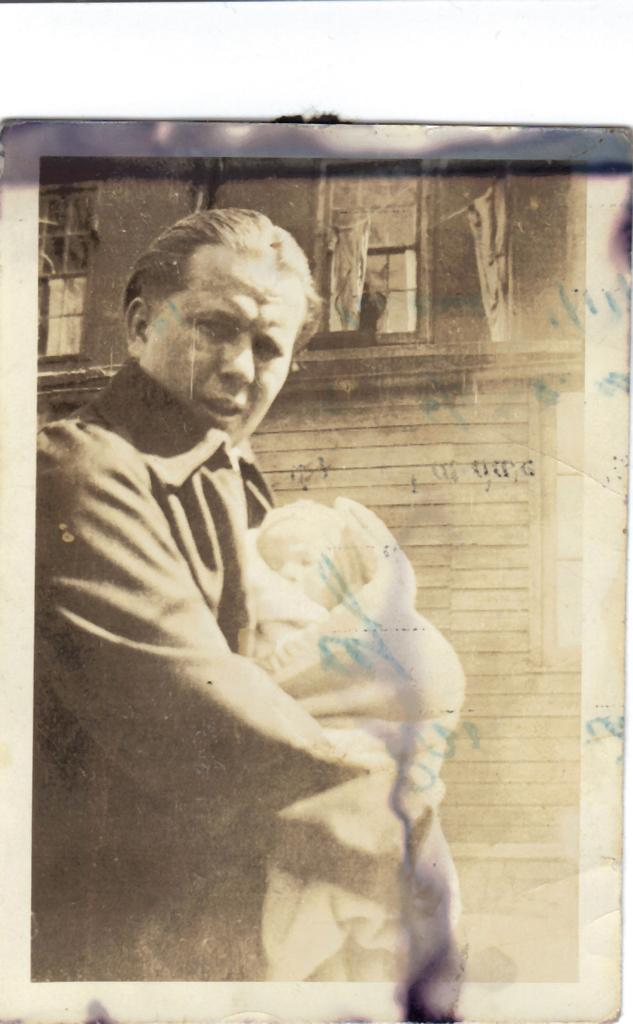What is depicted in the image? There is a photocopy of people in the image. What else can be seen in the image besides the photocopy? There is a wall visible in the image. What type of harmony is being played by the people in the image? There is no indication of music or harmony in the image, as it only features a photocopy of people and a wall. 